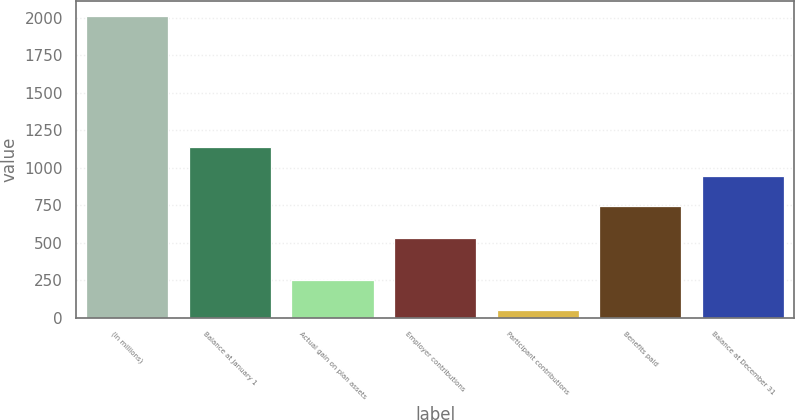Convert chart. <chart><loc_0><loc_0><loc_500><loc_500><bar_chart><fcel>(In millions)<fcel>Balance at January 1<fcel>Actual gain on plan assets<fcel>Employer contributions<fcel>Participant contributions<fcel>Benefits paid<fcel>Balance at December 31<nl><fcel>2013<fcel>1138.2<fcel>248.1<fcel>533<fcel>52<fcel>746<fcel>942.1<nl></chart> 